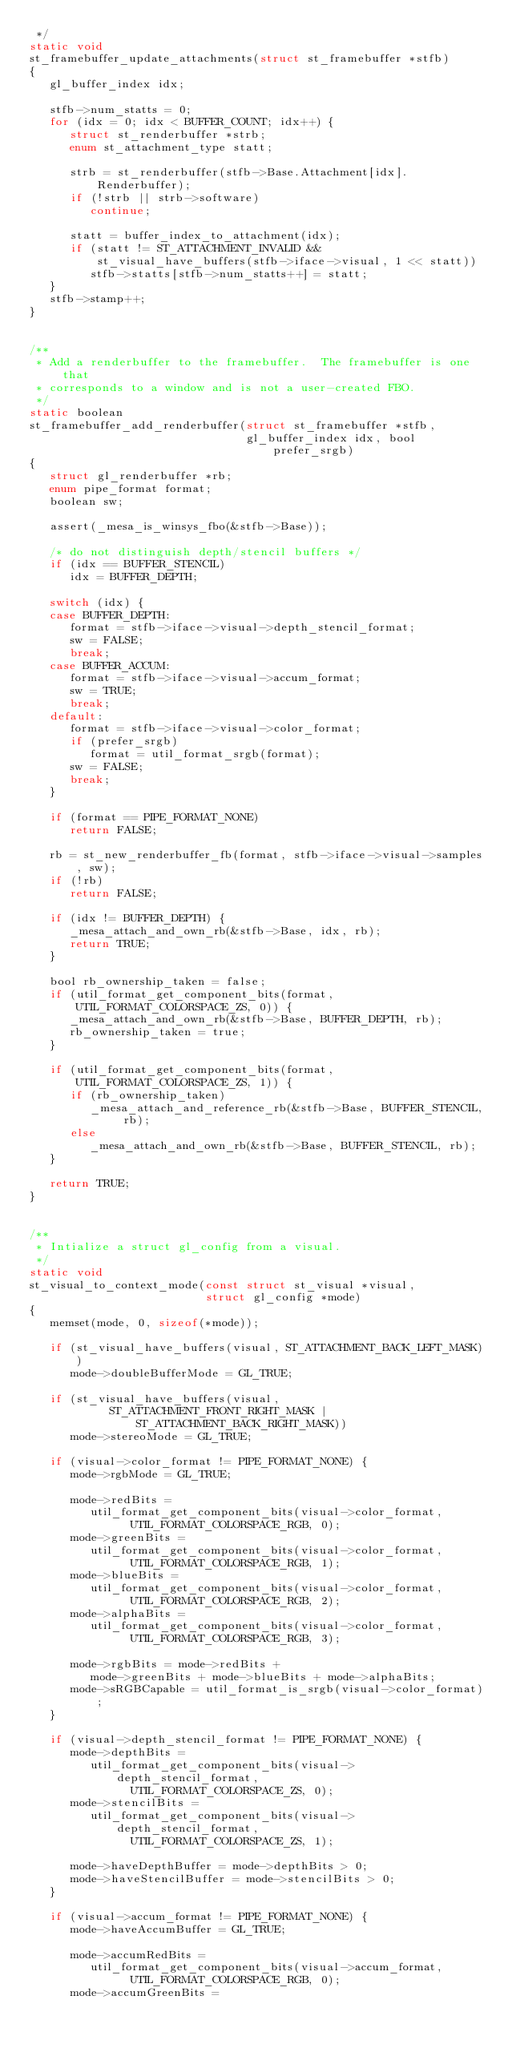<code> <loc_0><loc_0><loc_500><loc_500><_C_> */
static void
st_framebuffer_update_attachments(struct st_framebuffer *stfb)
{
   gl_buffer_index idx;

   stfb->num_statts = 0;
   for (idx = 0; idx < BUFFER_COUNT; idx++) {
      struct st_renderbuffer *strb;
      enum st_attachment_type statt;

      strb = st_renderbuffer(stfb->Base.Attachment[idx].Renderbuffer);
      if (!strb || strb->software)
         continue;

      statt = buffer_index_to_attachment(idx);
      if (statt != ST_ATTACHMENT_INVALID &&
          st_visual_have_buffers(stfb->iface->visual, 1 << statt))
         stfb->statts[stfb->num_statts++] = statt;
   }
   stfb->stamp++;
}


/**
 * Add a renderbuffer to the framebuffer.  The framebuffer is one that
 * corresponds to a window and is not a user-created FBO.
 */
static boolean
st_framebuffer_add_renderbuffer(struct st_framebuffer *stfb,
                                gl_buffer_index idx, bool prefer_srgb)
{
   struct gl_renderbuffer *rb;
   enum pipe_format format;
   boolean sw;

   assert(_mesa_is_winsys_fbo(&stfb->Base));

   /* do not distinguish depth/stencil buffers */
   if (idx == BUFFER_STENCIL)
      idx = BUFFER_DEPTH;

   switch (idx) {
   case BUFFER_DEPTH:
      format = stfb->iface->visual->depth_stencil_format;
      sw = FALSE;
      break;
   case BUFFER_ACCUM:
      format = stfb->iface->visual->accum_format;
      sw = TRUE;
      break;
   default:
      format = stfb->iface->visual->color_format;
      if (prefer_srgb)
         format = util_format_srgb(format);
      sw = FALSE;
      break;
   }

   if (format == PIPE_FORMAT_NONE)
      return FALSE;

   rb = st_new_renderbuffer_fb(format, stfb->iface->visual->samples, sw);
   if (!rb)
      return FALSE;

   if (idx != BUFFER_DEPTH) {
      _mesa_attach_and_own_rb(&stfb->Base, idx, rb);
      return TRUE;
   }

   bool rb_ownership_taken = false;
   if (util_format_get_component_bits(format, UTIL_FORMAT_COLORSPACE_ZS, 0)) {
      _mesa_attach_and_own_rb(&stfb->Base, BUFFER_DEPTH, rb);
      rb_ownership_taken = true;
   }

   if (util_format_get_component_bits(format, UTIL_FORMAT_COLORSPACE_ZS, 1)) {
      if (rb_ownership_taken)
         _mesa_attach_and_reference_rb(&stfb->Base, BUFFER_STENCIL, rb);
      else
         _mesa_attach_and_own_rb(&stfb->Base, BUFFER_STENCIL, rb);
   }

   return TRUE;
}


/**
 * Intialize a struct gl_config from a visual.
 */
static void
st_visual_to_context_mode(const struct st_visual *visual,
                          struct gl_config *mode)
{
   memset(mode, 0, sizeof(*mode));

   if (st_visual_have_buffers(visual, ST_ATTACHMENT_BACK_LEFT_MASK))
      mode->doubleBufferMode = GL_TRUE;

   if (st_visual_have_buffers(visual,
            ST_ATTACHMENT_FRONT_RIGHT_MASK | ST_ATTACHMENT_BACK_RIGHT_MASK))
      mode->stereoMode = GL_TRUE;

   if (visual->color_format != PIPE_FORMAT_NONE) {
      mode->rgbMode = GL_TRUE;

      mode->redBits =
         util_format_get_component_bits(visual->color_format,
               UTIL_FORMAT_COLORSPACE_RGB, 0);
      mode->greenBits =
         util_format_get_component_bits(visual->color_format,
               UTIL_FORMAT_COLORSPACE_RGB, 1);
      mode->blueBits =
         util_format_get_component_bits(visual->color_format,
               UTIL_FORMAT_COLORSPACE_RGB, 2);
      mode->alphaBits =
         util_format_get_component_bits(visual->color_format,
               UTIL_FORMAT_COLORSPACE_RGB, 3);

      mode->rgbBits = mode->redBits +
         mode->greenBits + mode->blueBits + mode->alphaBits;
      mode->sRGBCapable = util_format_is_srgb(visual->color_format);
   }

   if (visual->depth_stencil_format != PIPE_FORMAT_NONE) {
      mode->depthBits =
         util_format_get_component_bits(visual->depth_stencil_format,
               UTIL_FORMAT_COLORSPACE_ZS, 0);
      mode->stencilBits =
         util_format_get_component_bits(visual->depth_stencil_format,
               UTIL_FORMAT_COLORSPACE_ZS, 1);

      mode->haveDepthBuffer = mode->depthBits > 0;
      mode->haveStencilBuffer = mode->stencilBits > 0;
   }

   if (visual->accum_format != PIPE_FORMAT_NONE) {
      mode->haveAccumBuffer = GL_TRUE;

      mode->accumRedBits =
         util_format_get_component_bits(visual->accum_format,
               UTIL_FORMAT_COLORSPACE_RGB, 0);
      mode->accumGreenBits =</code> 